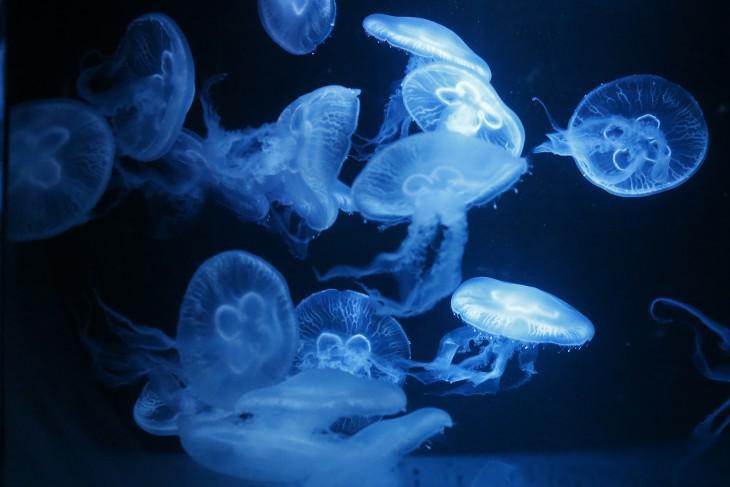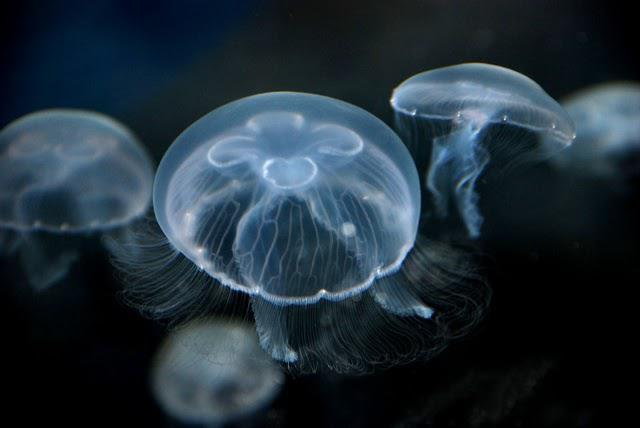The first image is the image on the left, the second image is the image on the right. Given the left and right images, does the statement "There are no more than 5 jellyfish in the image on the right." hold true? Answer yes or no. Yes. 